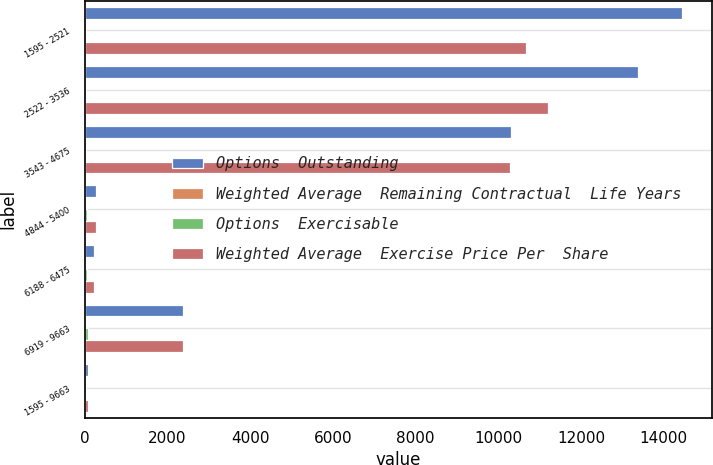<chart> <loc_0><loc_0><loc_500><loc_500><stacked_bar_chart><ecel><fcel>1595 - 2521<fcel>2522 - 3536<fcel>3543 - 4675<fcel>4844 - 5400<fcel>6188 - 6475<fcel>6919 - 9663<fcel>1595 - 9663<nl><fcel>Options  Outstanding<fcel>14454<fcel>13381<fcel>10299<fcel>276<fcel>230<fcel>2381<fcel>71.33<nl><fcel>Weighted Average  Remaining Contractual  Life Years<fcel>4.75<fcel>5.01<fcel>3.53<fcel>1.58<fcel>1.02<fcel>1.16<fcel>4.28<nl><fcel>Options  Exercisable<fcel>22.59<fcel>28.39<fcel>39.82<fcel>50.04<fcel>63.53<fcel>79.13<fcel>32.51<nl><fcel>Weighted Average  Exercise Price Per  Share<fcel>10681<fcel>11196<fcel>10295<fcel>276<fcel>230<fcel>2381<fcel>71.33<nl></chart> 